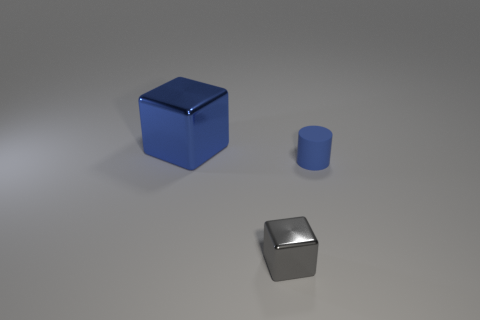How would these objects interact with light in a real-world setting? In the real world, the metallic cube would likely reflect a significant amount of light, causing bright highlights and possibly casting complex reflections on nearby surfaces. The large blue cube and cylinder would reflect light as well, but with less intensity due to their less reflective finish. All objects would cast shadows that correspond to their shapes, and the intensity and angle of the incoming light would define the sharpness and length of those shadows. 